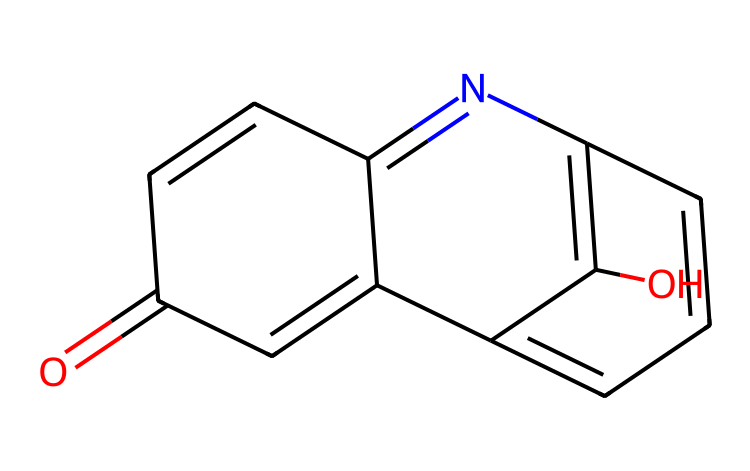What is the molecular formula of this compound? By analyzing the SMILES representation, we can count the number of each type of atom present: there are 14 carbon atoms, 9 hydrogen atoms, 2 nitrogen atoms, and 3 oxygen atoms. Therefore, the molecular formula is C14H9N2O3.
Answer: C14H9N2O3 How many double bonds are present in this structure? Examining the structure inferred from the SMILES, we can identify that there are multiple double bonds: particularly between carbon and nitrogen, and between different carbon atoms. Counting these, we find a total of 6 double bonds.
Answer: 6 What type of chemical structure does this represent? The presence of the diazo group (-N2) and a novolac resin framework indicates that this compound is a diazonaphthoquinone-novolac resin, which is commonly used in photolithography.
Answer: diazonaphthoquinone-novolac resin Which functional groups are present in this compound? By analyzing the SMILES, we can identify the presence of carbonyl groups (C=O), phenolic hydroxyl groups (-OH), and imine groups (C=N) in the structure. This indicates the compound has multiple functional groups.
Answer: carbonyl, phenolic, imine What is the primary application of diazonaphthoquinone-novolac resins? Diazonaphthoquinone-novolac resins are predominantly used in photolithography, which is a critical process in the production of microelectronics and integrated circuits due to their sensitivity to light.
Answer: photolithography How does the presence of nitrogen affect the reactivity of this compound? The nitrogen atoms in the diazo and imine functional groups enhance the compound's reactivity towards light, allowing for a photochemical reaction that is crucial in the lithographic process.
Answer: enhances reactivity 